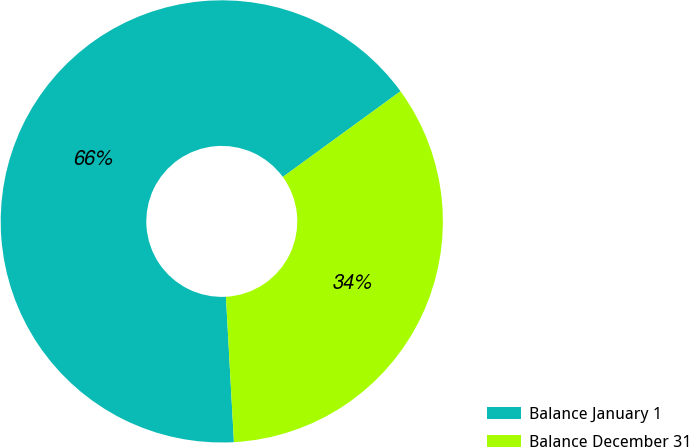Convert chart. <chart><loc_0><loc_0><loc_500><loc_500><pie_chart><fcel>Balance January 1<fcel>Balance December 31<nl><fcel>65.86%<fcel>34.14%<nl></chart> 